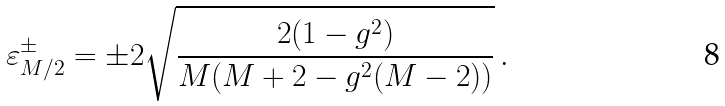Convert formula to latex. <formula><loc_0><loc_0><loc_500><loc_500>\varepsilon _ { M / 2 } ^ { \pm } = \pm 2 \sqrt { \frac { 2 ( 1 - g ^ { 2 } ) } { M ( M + 2 - g ^ { 2 } ( M - 2 ) ) } } \, .</formula> 